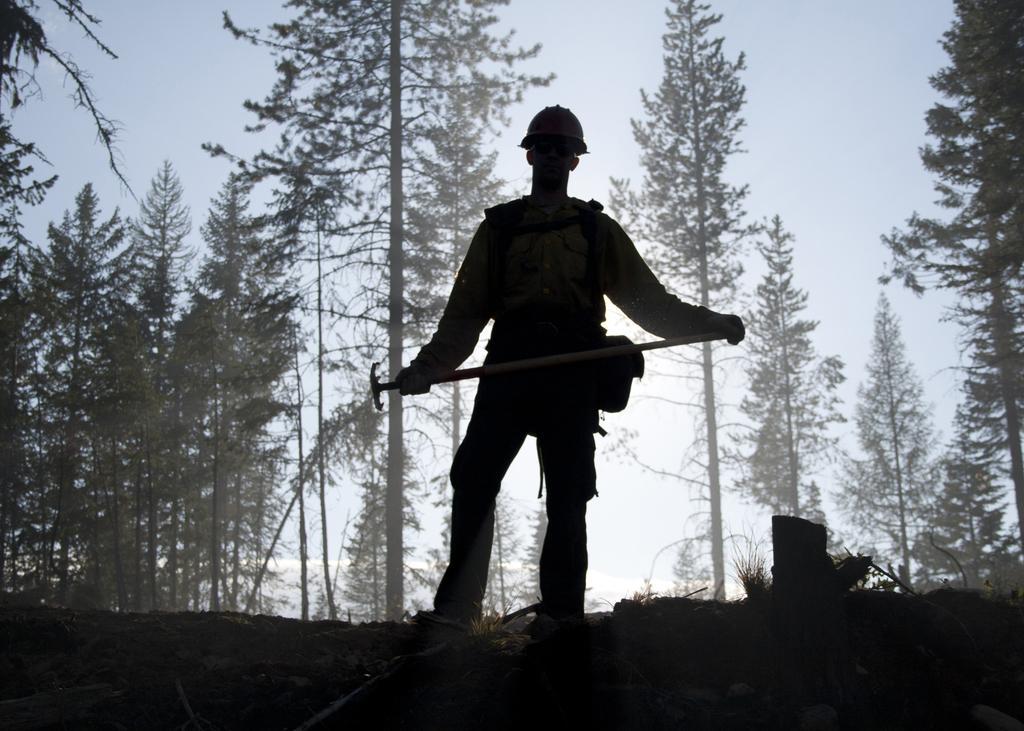Please provide a concise description of this image. In this image I can see a person holding something in his hands. In the background, I can see the trees and the sky. 